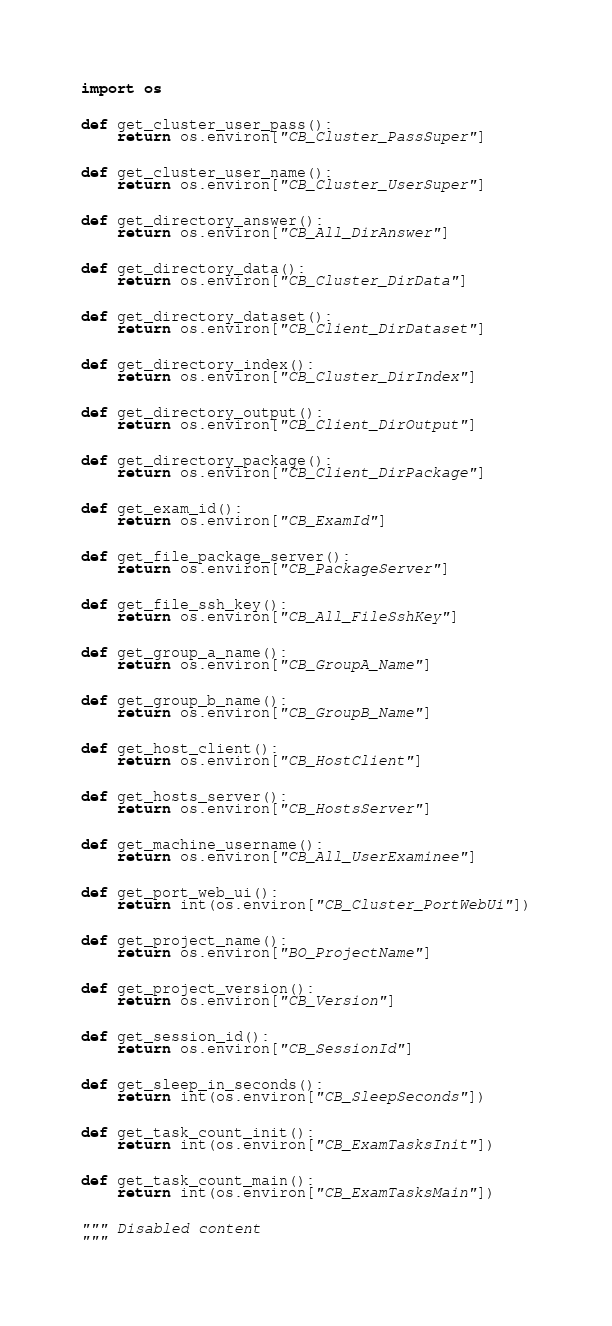<code> <loc_0><loc_0><loc_500><loc_500><_Python_>import os


def get_cluster_user_pass():
    return os.environ["CB_Cluster_PassSuper"]


def get_cluster_user_name():
    return os.environ["CB_Cluster_UserSuper"]


def get_directory_answer():
    return os.environ["CB_All_DirAnswer"]


def get_directory_data():
    return os.environ["CB_Cluster_DirData"]


def get_directory_dataset():
    return os.environ["CB_Client_DirDataset"]


def get_directory_index():
    return os.environ["CB_Cluster_DirIndex"]


def get_directory_output():
    return os.environ["CB_Client_DirOutput"]


def get_directory_package():
    return os.environ["CB_Client_DirPackage"]


def get_exam_id():
    return os.environ["CB_ExamId"]


def get_file_package_server():
    return os.environ["CB_PackageServer"]


def get_file_ssh_key():
    return os.environ["CB_All_FileSshKey"]


def get_group_a_name():
    return os.environ["CB_GroupA_Name"]


def get_group_b_name():
    return os.environ["CB_GroupB_Name"]


def get_host_client():
    return os.environ["CB_HostClient"]


def get_hosts_server():
    return os.environ["CB_HostsServer"]


def get_machine_username():
    return os.environ["CB_All_UserExaminee"]


def get_port_web_ui():
    return int(os.environ["CB_Cluster_PortWebUi"])


def get_project_name():
    return os.environ["BO_ProjectName"]


def get_project_version():
    return os.environ["CB_Version"]


def get_session_id():
    return os.environ["CB_SessionId"]


def get_sleep_in_seconds():
    return int(os.environ["CB_SleepSeconds"])


def get_task_count_init():
    return int(os.environ["CB_ExamTasksInit"])


def get_task_count_main():
    return int(os.environ["CB_ExamTasksMain"])


""" Disabled content
"""
</code> 